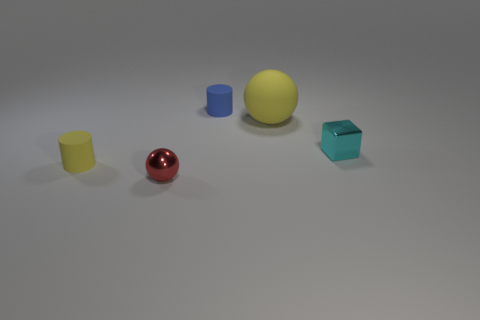Add 4 tiny yellow rubber objects. How many objects exist? 9 Subtract all blocks. How many objects are left? 4 Add 5 blue rubber cylinders. How many blue rubber cylinders are left? 6 Add 1 matte cylinders. How many matte cylinders exist? 3 Subtract 0 brown cubes. How many objects are left? 5 Subtract all large yellow rubber objects. Subtract all yellow cylinders. How many objects are left? 3 